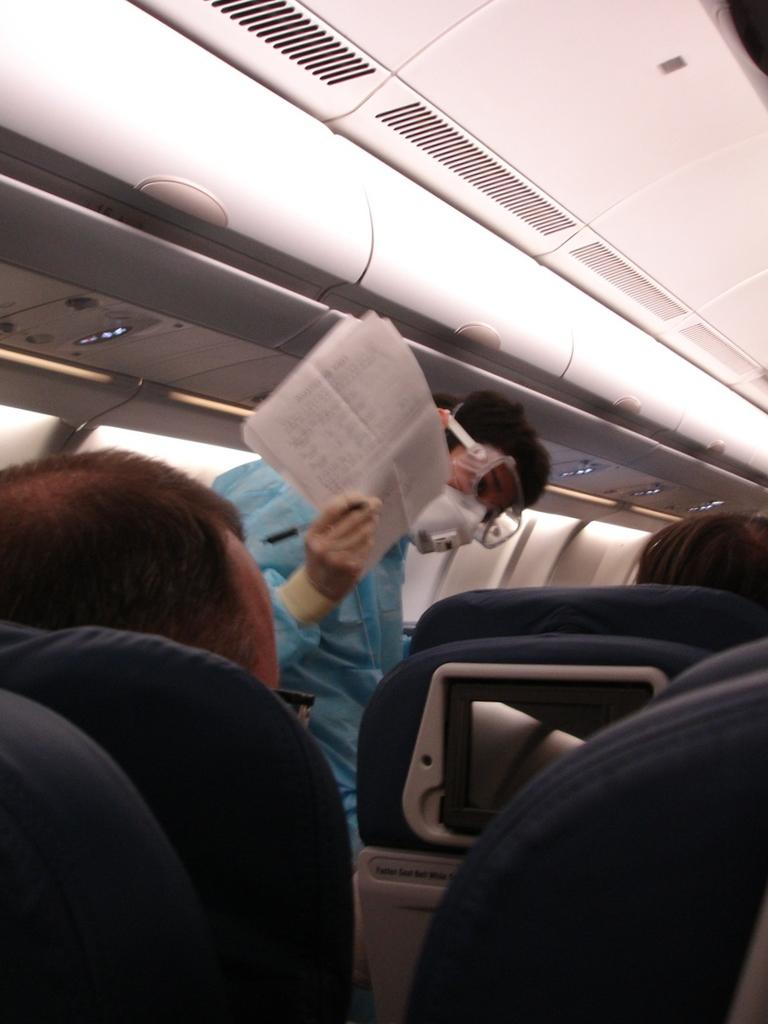What is the setting of the image? The image shows the inside of a vehicle. Can you describe the people inside the vehicle? There are people visible inside the vehicle. What type of treatment is being administered to the kettle in the image? There is no kettle present in the image, so no treatment can be administered to it. 